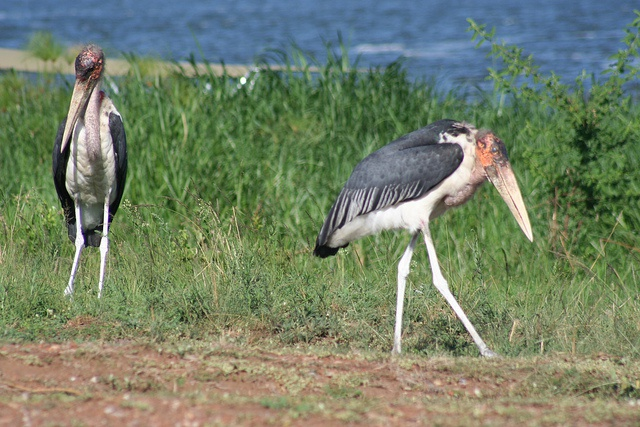Describe the objects in this image and their specific colors. I can see bird in gray, white, and darkgray tones and bird in gray, black, lightgray, and darkgray tones in this image. 